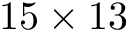<formula> <loc_0><loc_0><loc_500><loc_500>1 5 \times 1 3</formula> 